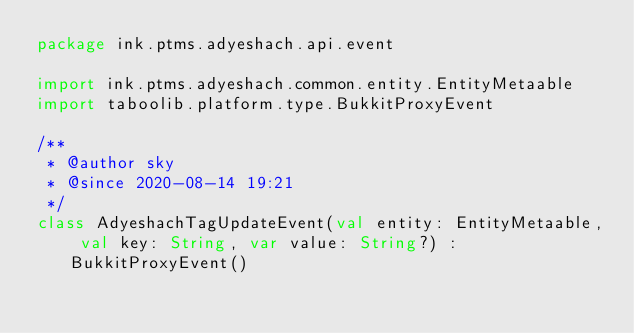<code> <loc_0><loc_0><loc_500><loc_500><_Kotlin_>package ink.ptms.adyeshach.api.event

import ink.ptms.adyeshach.common.entity.EntityMetaable
import taboolib.platform.type.BukkitProxyEvent

/**
 * @author sky
 * @since 2020-08-14 19:21
 */
class AdyeshachTagUpdateEvent(val entity: EntityMetaable, val key: String, var value: String?) : BukkitProxyEvent()</code> 